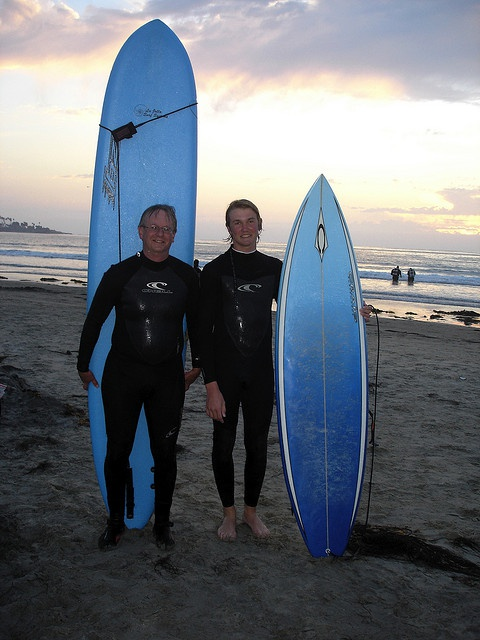Describe the objects in this image and their specific colors. I can see surfboard in darkgray, navy, blue, and darkblue tones, people in darkgray, black, gray, blue, and maroon tones, surfboard in darkgray, blue, and gray tones, people in darkgray, black, maroon, and gray tones, and people in darkgray, black, and gray tones in this image. 